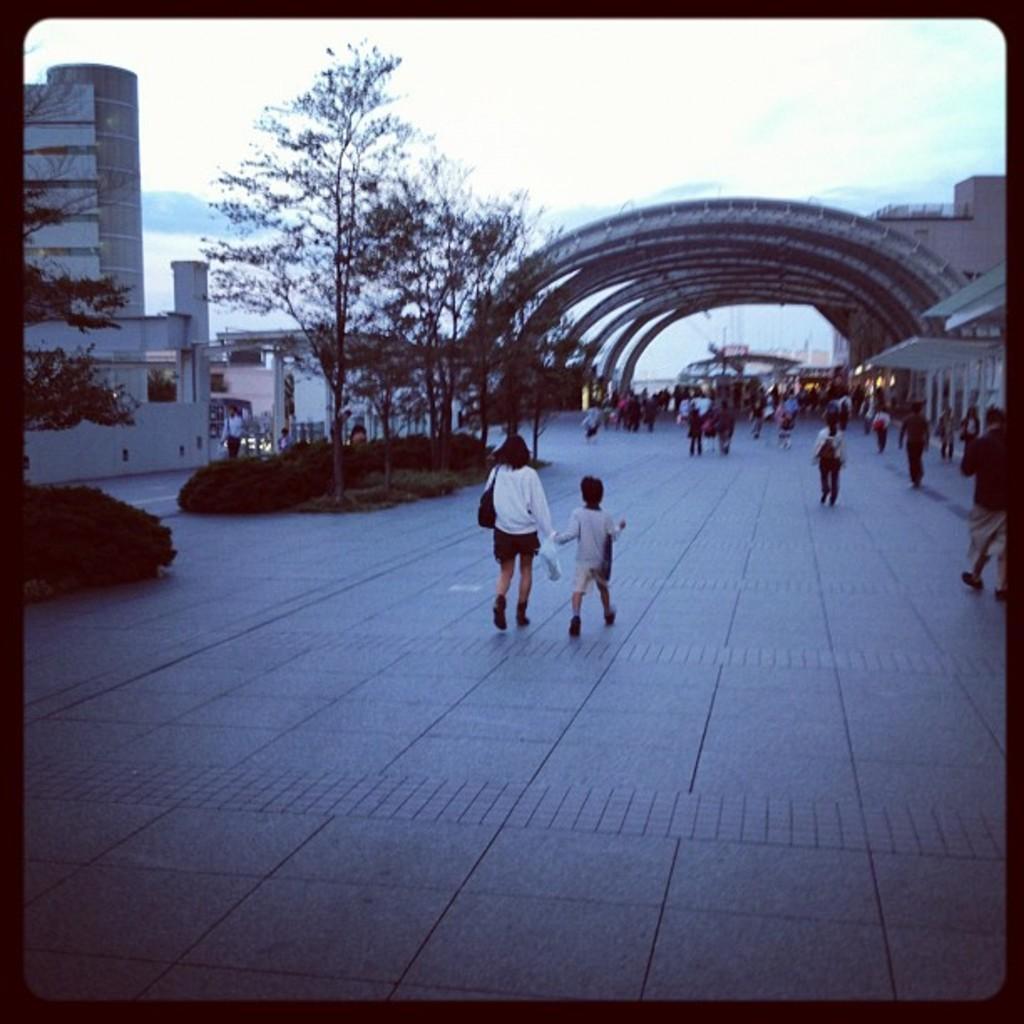Could you give a brief overview of what you see in this image? This is an edited image. I can see groups of people walking. There are trees, bushes and buildings. In the background, there is the sky. 